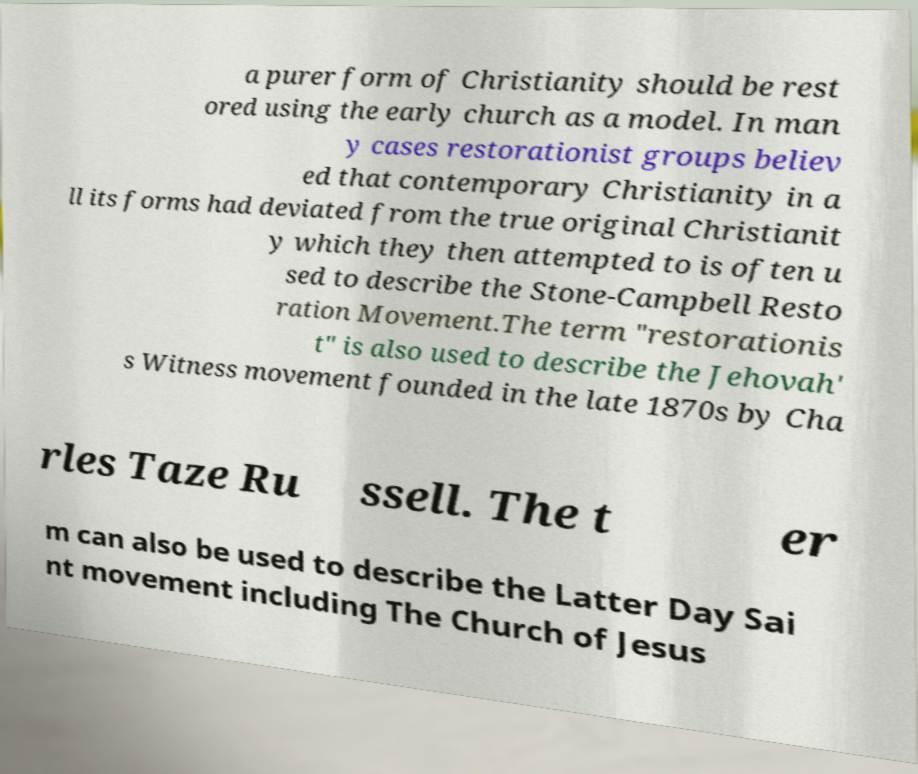Please read and relay the text visible in this image. What does it say? a purer form of Christianity should be rest ored using the early church as a model. In man y cases restorationist groups believ ed that contemporary Christianity in a ll its forms had deviated from the true original Christianit y which they then attempted to is often u sed to describe the Stone-Campbell Resto ration Movement.The term "restorationis t" is also used to describe the Jehovah' s Witness movement founded in the late 1870s by Cha rles Taze Ru ssell. The t er m can also be used to describe the Latter Day Sai nt movement including The Church of Jesus 